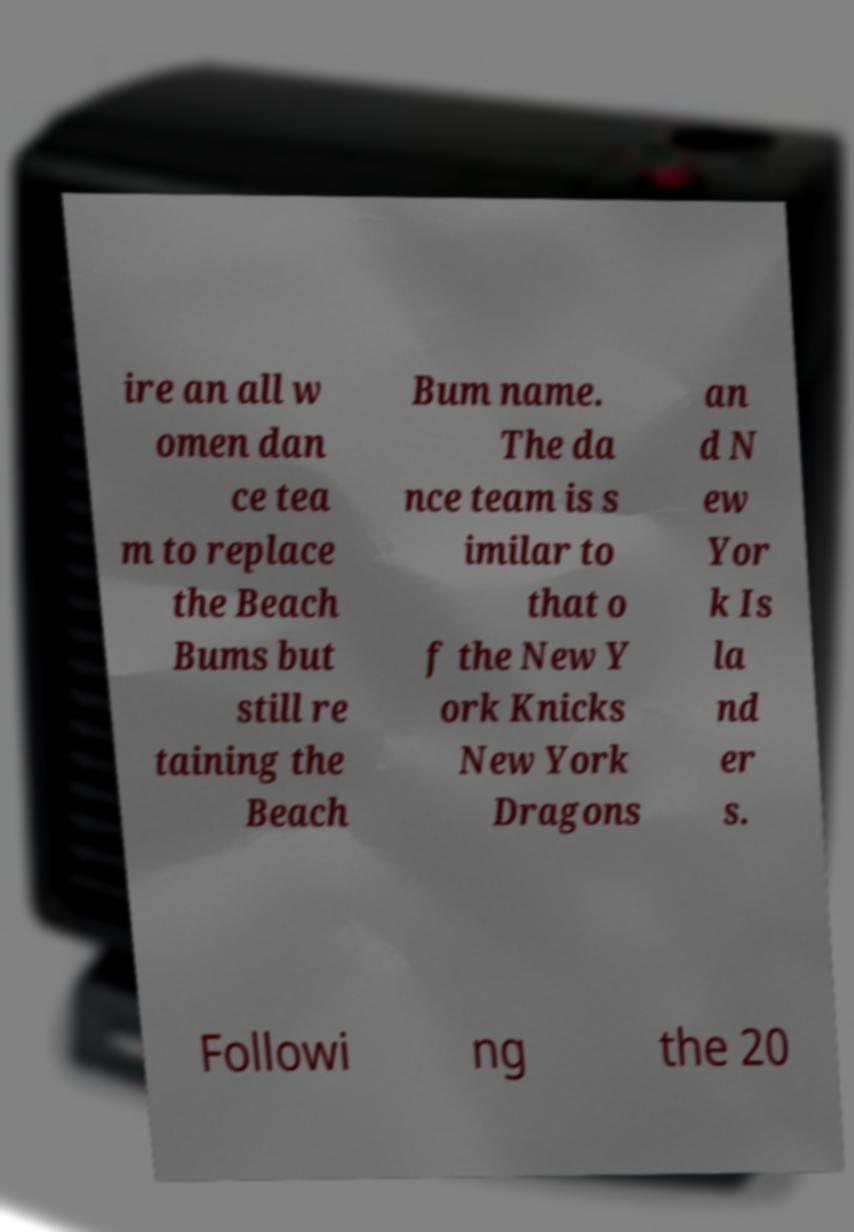Could you extract and type out the text from this image? ire an all w omen dan ce tea m to replace the Beach Bums but still re taining the Beach Bum name. The da nce team is s imilar to that o f the New Y ork Knicks New York Dragons an d N ew Yor k Is la nd er s. Followi ng the 20 